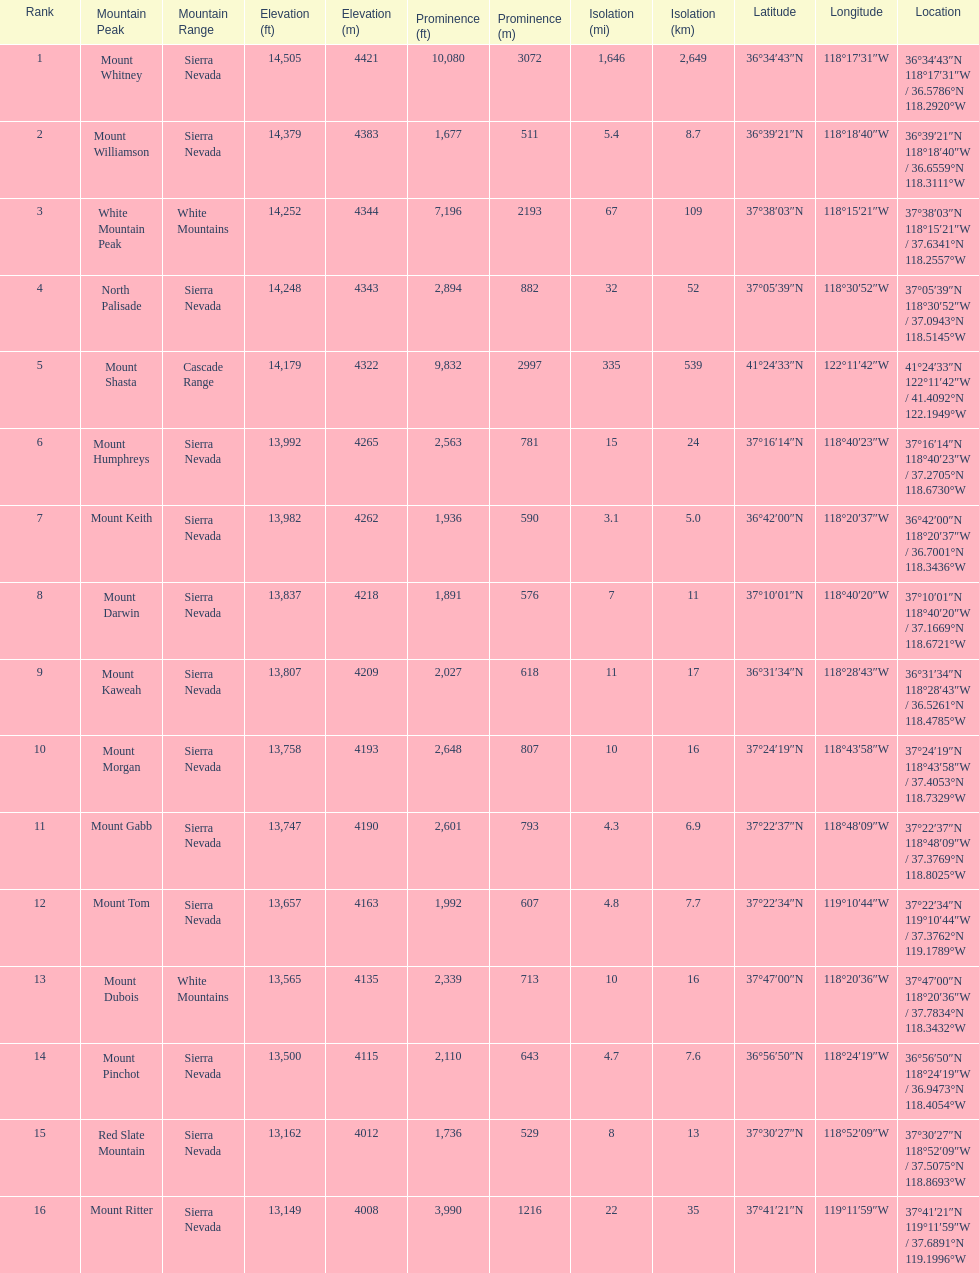Which is taller, mount humphreys or mount kaweah. Mount Humphreys. 